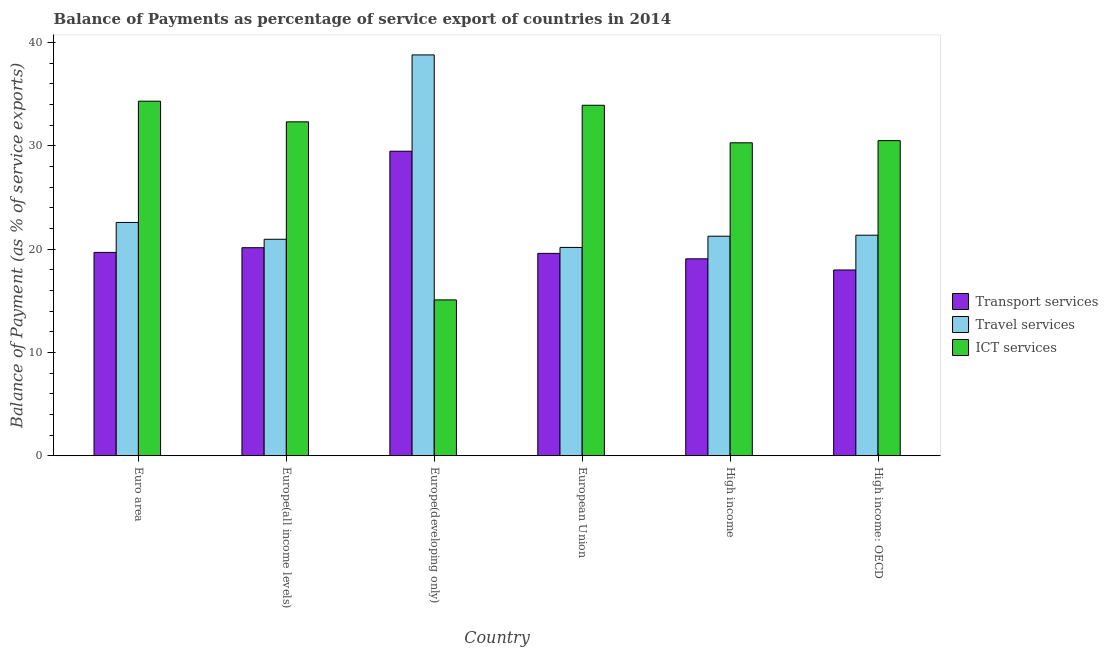How many different coloured bars are there?
Your answer should be compact. 3. How many groups of bars are there?
Keep it short and to the point. 6. How many bars are there on the 6th tick from the right?
Your answer should be compact. 3. What is the label of the 6th group of bars from the left?
Keep it short and to the point. High income: OECD. What is the balance of payment of ict services in Euro area?
Your answer should be compact. 34.34. Across all countries, what is the maximum balance of payment of travel services?
Keep it short and to the point. 38.82. Across all countries, what is the minimum balance of payment of travel services?
Your response must be concise. 20.17. In which country was the balance of payment of ict services maximum?
Keep it short and to the point. Euro area. What is the total balance of payment of ict services in the graph?
Ensure brevity in your answer.  176.52. What is the difference between the balance of payment of transport services in Euro area and that in High income?
Your answer should be very brief. 0.62. What is the difference between the balance of payment of transport services in European Union and the balance of payment of ict services in Europe(developing only)?
Your answer should be compact. 4.5. What is the average balance of payment of ict services per country?
Provide a succinct answer. 29.42. What is the difference between the balance of payment of transport services and balance of payment of travel services in Europe(all income levels)?
Your answer should be very brief. -0.82. In how many countries, is the balance of payment of travel services greater than 32 %?
Provide a short and direct response. 1. What is the ratio of the balance of payment of ict services in Euro area to that in Europe(developing only)?
Provide a short and direct response. 2.28. Is the difference between the balance of payment of transport services in Europe(all income levels) and Europe(developing only) greater than the difference between the balance of payment of travel services in Europe(all income levels) and Europe(developing only)?
Offer a terse response. Yes. What is the difference between the highest and the second highest balance of payment of transport services?
Your response must be concise. 9.34. What is the difference between the highest and the lowest balance of payment of transport services?
Keep it short and to the point. 11.5. What does the 1st bar from the left in Euro area represents?
Give a very brief answer. Transport services. What does the 3rd bar from the right in Europe(developing only) represents?
Offer a terse response. Transport services. Is it the case that in every country, the sum of the balance of payment of transport services and balance of payment of travel services is greater than the balance of payment of ict services?
Offer a very short reply. Yes. Are all the bars in the graph horizontal?
Offer a terse response. No. What is the difference between two consecutive major ticks on the Y-axis?
Your answer should be compact. 10. Are the values on the major ticks of Y-axis written in scientific E-notation?
Provide a short and direct response. No. Where does the legend appear in the graph?
Offer a very short reply. Center right. What is the title of the graph?
Make the answer very short. Balance of Payments as percentage of service export of countries in 2014. What is the label or title of the X-axis?
Offer a terse response. Country. What is the label or title of the Y-axis?
Your response must be concise. Balance of Payment (as % of service exports). What is the Balance of Payment (as % of service exports) in Transport services in Euro area?
Give a very brief answer. 19.69. What is the Balance of Payment (as % of service exports) in Travel services in Euro area?
Provide a succinct answer. 22.59. What is the Balance of Payment (as % of service exports) in ICT services in Euro area?
Provide a succinct answer. 34.34. What is the Balance of Payment (as % of service exports) in Transport services in Europe(all income levels)?
Offer a terse response. 20.15. What is the Balance of Payment (as % of service exports) in Travel services in Europe(all income levels)?
Give a very brief answer. 20.96. What is the Balance of Payment (as % of service exports) in ICT services in Europe(all income levels)?
Your answer should be compact. 32.34. What is the Balance of Payment (as % of service exports) in Transport services in Europe(developing only)?
Make the answer very short. 29.49. What is the Balance of Payment (as % of service exports) in Travel services in Europe(developing only)?
Provide a succinct answer. 38.82. What is the Balance of Payment (as % of service exports) in ICT services in Europe(developing only)?
Your answer should be compact. 15.09. What is the Balance of Payment (as % of service exports) in Transport services in European Union?
Ensure brevity in your answer.  19.6. What is the Balance of Payment (as % of service exports) of Travel services in European Union?
Ensure brevity in your answer.  20.17. What is the Balance of Payment (as % of service exports) in ICT services in European Union?
Ensure brevity in your answer.  33.94. What is the Balance of Payment (as % of service exports) in Transport services in High income?
Ensure brevity in your answer.  19.07. What is the Balance of Payment (as % of service exports) of Travel services in High income?
Offer a very short reply. 21.26. What is the Balance of Payment (as % of service exports) of ICT services in High income?
Your answer should be very brief. 30.3. What is the Balance of Payment (as % of service exports) in Transport services in High income: OECD?
Ensure brevity in your answer.  17.99. What is the Balance of Payment (as % of service exports) of Travel services in High income: OECD?
Ensure brevity in your answer.  21.36. What is the Balance of Payment (as % of service exports) in ICT services in High income: OECD?
Offer a very short reply. 30.52. Across all countries, what is the maximum Balance of Payment (as % of service exports) of Transport services?
Offer a very short reply. 29.49. Across all countries, what is the maximum Balance of Payment (as % of service exports) in Travel services?
Offer a terse response. 38.82. Across all countries, what is the maximum Balance of Payment (as % of service exports) in ICT services?
Keep it short and to the point. 34.34. Across all countries, what is the minimum Balance of Payment (as % of service exports) in Transport services?
Give a very brief answer. 17.99. Across all countries, what is the minimum Balance of Payment (as % of service exports) of Travel services?
Offer a very short reply. 20.17. Across all countries, what is the minimum Balance of Payment (as % of service exports) of ICT services?
Offer a very short reply. 15.09. What is the total Balance of Payment (as % of service exports) in Transport services in the graph?
Make the answer very short. 125.98. What is the total Balance of Payment (as % of service exports) in Travel services in the graph?
Your answer should be compact. 145.16. What is the total Balance of Payment (as % of service exports) in ICT services in the graph?
Your answer should be compact. 176.52. What is the difference between the Balance of Payment (as % of service exports) of Transport services in Euro area and that in Europe(all income levels)?
Your response must be concise. -0.45. What is the difference between the Balance of Payment (as % of service exports) of Travel services in Euro area and that in Europe(all income levels)?
Ensure brevity in your answer.  1.63. What is the difference between the Balance of Payment (as % of service exports) of ICT services in Euro area and that in Europe(all income levels)?
Ensure brevity in your answer.  2. What is the difference between the Balance of Payment (as % of service exports) in Transport services in Euro area and that in Europe(developing only)?
Offer a terse response. -9.8. What is the difference between the Balance of Payment (as % of service exports) in Travel services in Euro area and that in Europe(developing only)?
Your answer should be compact. -16.23. What is the difference between the Balance of Payment (as % of service exports) in ICT services in Euro area and that in Europe(developing only)?
Provide a short and direct response. 19.24. What is the difference between the Balance of Payment (as % of service exports) in Transport services in Euro area and that in European Union?
Offer a terse response. 0.1. What is the difference between the Balance of Payment (as % of service exports) of Travel services in Euro area and that in European Union?
Offer a very short reply. 2.42. What is the difference between the Balance of Payment (as % of service exports) of ICT services in Euro area and that in European Union?
Give a very brief answer. 0.4. What is the difference between the Balance of Payment (as % of service exports) of Transport services in Euro area and that in High income?
Offer a terse response. 0.62. What is the difference between the Balance of Payment (as % of service exports) of Travel services in Euro area and that in High income?
Keep it short and to the point. 1.33. What is the difference between the Balance of Payment (as % of service exports) in ICT services in Euro area and that in High income?
Make the answer very short. 4.03. What is the difference between the Balance of Payment (as % of service exports) of Transport services in Euro area and that in High income: OECD?
Offer a very short reply. 1.7. What is the difference between the Balance of Payment (as % of service exports) in Travel services in Euro area and that in High income: OECD?
Offer a terse response. 1.23. What is the difference between the Balance of Payment (as % of service exports) in ICT services in Euro area and that in High income: OECD?
Your answer should be compact. 3.82. What is the difference between the Balance of Payment (as % of service exports) of Transport services in Europe(all income levels) and that in Europe(developing only)?
Provide a succinct answer. -9.34. What is the difference between the Balance of Payment (as % of service exports) of Travel services in Europe(all income levels) and that in Europe(developing only)?
Provide a short and direct response. -17.85. What is the difference between the Balance of Payment (as % of service exports) of ICT services in Europe(all income levels) and that in Europe(developing only)?
Your answer should be very brief. 17.24. What is the difference between the Balance of Payment (as % of service exports) in Transport services in Europe(all income levels) and that in European Union?
Give a very brief answer. 0.55. What is the difference between the Balance of Payment (as % of service exports) in Travel services in Europe(all income levels) and that in European Union?
Give a very brief answer. 0.79. What is the difference between the Balance of Payment (as % of service exports) of ICT services in Europe(all income levels) and that in European Union?
Offer a terse response. -1.6. What is the difference between the Balance of Payment (as % of service exports) in Transport services in Europe(all income levels) and that in High income?
Your answer should be compact. 1.08. What is the difference between the Balance of Payment (as % of service exports) of Travel services in Europe(all income levels) and that in High income?
Your answer should be compact. -0.3. What is the difference between the Balance of Payment (as % of service exports) of ICT services in Europe(all income levels) and that in High income?
Give a very brief answer. 2.03. What is the difference between the Balance of Payment (as % of service exports) of Transport services in Europe(all income levels) and that in High income: OECD?
Your answer should be very brief. 2.16. What is the difference between the Balance of Payment (as % of service exports) of Travel services in Europe(all income levels) and that in High income: OECD?
Make the answer very short. -0.4. What is the difference between the Balance of Payment (as % of service exports) of ICT services in Europe(all income levels) and that in High income: OECD?
Offer a terse response. 1.82. What is the difference between the Balance of Payment (as % of service exports) in Transport services in Europe(developing only) and that in European Union?
Make the answer very short. 9.89. What is the difference between the Balance of Payment (as % of service exports) in Travel services in Europe(developing only) and that in European Union?
Provide a short and direct response. 18.64. What is the difference between the Balance of Payment (as % of service exports) of ICT services in Europe(developing only) and that in European Union?
Your answer should be compact. -18.85. What is the difference between the Balance of Payment (as % of service exports) in Transport services in Europe(developing only) and that in High income?
Make the answer very short. 10.42. What is the difference between the Balance of Payment (as % of service exports) in Travel services in Europe(developing only) and that in High income?
Keep it short and to the point. 17.56. What is the difference between the Balance of Payment (as % of service exports) of ICT services in Europe(developing only) and that in High income?
Give a very brief answer. -15.21. What is the difference between the Balance of Payment (as % of service exports) of Transport services in Europe(developing only) and that in High income: OECD?
Offer a terse response. 11.5. What is the difference between the Balance of Payment (as % of service exports) in Travel services in Europe(developing only) and that in High income: OECD?
Ensure brevity in your answer.  17.46. What is the difference between the Balance of Payment (as % of service exports) in ICT services in Europe(developing only) and that in High income: OECD?
Offer a very short reply. -15.42. What is the difference between the Balance of Payment (as % of service exports) of Transport services in European Union and that in High income?
Offer a very short reply. 0.53. What is the difference between the Balance of Payment (as % of service exports) of Travel services in European Union and that in High income?
Keep it short and to the point. -1.09. What is the difference between the Balance of Payment (as % of service exports) in ICT services in European Union and that in High income?
Ensure brevity in your answer.  3.64. What is the difference between the Balance of Payment (as % of service exports) of Transport services in European Union and that in High income: OECD?
Provide a succinct answer. 1.61. What is the difference between the Balance of Payment (as % of service exports) of Travel services in European Union and that in High income: OECD?
Offer a very short reply. -1.19. What is the difference between the Balance of Payment (as % of service exports) in ICT services in European Union and that in High income: OECD?
Your answer should be very brief. 3.42. What is the difference between the Balance of Payment (as % of service exports) of Transport services in High income and that in High income: OECD?
Ensure brevity in your answer.  1.08. What is the difference between the Balance of Payment (as % of service exports) in Travel services in High income and that in High income: OECD?
Provide a succinct answer. -0.1. What is the difference between the Balance of Payment (as % of service exports) in ICT services in High income and that in High income: OECD?
Ensure brevity in your answer.  -0.21. What is the difference between the Balance of Payment (as % of service exports) in Transport services in Euro area and the Balance of Payment (as % of service exports) in Travel services in Europe(all income levels)?
Provide a short and direct response. -1.27. What is the difference between the Balance of Payment (as % of service exports) of Transport services in Euro area and the Balance of Payment (as % of service exports) of ICT services in Europe(all income levels)?
Make the answer very short. -12.64. What is the difference between the Balance of Payment (as % of service exports) in Travel services in Euro area and the Balance of Payment (as % of service exports) in ICT services in Europe(all income levels)?
Provide a succinct answer. -9.74. What is the difference between the Balance of Payment (as % of service exports) of Transport services in Euro area and the Balance of Payment (as % of service exports) of Travel services in Europe(developing only)?
Offer a very short reply. -19.12. What is the difference between the Balance of Payment (as % of service exports) of Transport services in Euro area and the Balance of Payment (as % of service exports) of ICT services in Europe(developing only)?
Make the answer very short. 4.6. What is the difference between the Balance of Payment (as % of service exports) of Travel services in Euro area and the Balance of Payment (as % of service exports) of ICT services in Europe(developing only)?
Your answer should be very brief. 7.5. What is the difference between the Balance of Payment (as % of service exports) in Transport services in Euro area and the Balance of Payment (as % of service exports) in Travel services in European Union?
Your answer should be very brief. -0.48. What is the difference between the Balance of Payment (as % of service exports) in Transport services in Euro area and the Balance of Payment (as % of service exports) in ICT services in European Union?
Provide a short and direct response. -14.25. What is the difference between the Balance of Payment (as % of service exports) of Travel services in Euro area and the Balance of Payment (as % of service exports) of ICT services in European Union?
Your answer should be very brief. -11.35. What is the difference between the Balance of Payment (as % of service exports) of Transport services in Euro area and the Balance of Payment (as % of service exports) of Travel services in High income?
Keep it short and to the point. -1.57. What is the difference between the Balance of Payment (as % of service exports) of Transport services in Euro area and the Balance of Payment (as % of service exports) of ICT services in High income?
Give a very brief answer. -10.61. What is the difference between the Balance of Payment (as % of service exports) of Travel services in Euro area and the Balance of Payment (as % of service exports) of ICT services in High income?
Give a very brief answer. -7.71. What is the difference between the Balance of Payment (as % of service exports) in Transport services in Euro area and the Balance of Payment (as % of service exports) in Travel services in High income: OECD?
Keep it short and to the point. -1.67. What is the difference between the Balance of Payment (as % of service exports) in Transport services in Euro area and the Balance of Payment (as % of service exports) in ICT services in High income: OECD?
Your answer should be compact. -10.82. What is the difference between the Balance of Payment (as % of service exports) of Travel services in Euro area and the Balance of Payment (as % of service exports) of ICT services in High income: OECD?
Provide a short and direct response. -7.92. What is the difference between the Balance of Payment (as % of service exports) in Transport services in Europe(all income levels) and the Balance of Payment (as % of service exports) in Travel services in Europe(developing only)?
Make the answer very short. -18.67. What is the difference between the Balance of Payment (as % of service exports) in Transport services in Europe(all income levels) and the Balance of Payment (as % of service exports) in ICT services in Europe(developing only)?
Your response must be concise. 5.05. What is the difference between the Balance of Payment (as % of service exports) in Travel services in Europe(all income levels) and the Balance of Payment (as % of service exports) in ICT services in Europe(developing only)?
Provide a succinct answer. 5.87. What is the difference between the Balance of Payment (as % of service exports) of Transport services in Europe(all income levels) and the Balance of Payment (as % of service exports) of Travel services in European Union?
Your answer should be very brief. -0.03. What is the difference between the Balance of Payment (as % of service exports) of Transport services in Europe(all income levels) and the Balance of Payment (as % of service exports) of ICT services in European Union?
Ensure brevity in your answer.  -13.79. What is the difference between the Balance of Payment (as % of service exports) in Travel services in Europe(all income levels) and the Balance of Payment (as % of service exports) in ICT services in European Union?
Your answer should be very brief. -12.98. What is the difference between the Balance of Payment (as % of service exports) of Transport services in Europe(all income levels) and the Balance of Payment (as % of service exports) of Travel services in High income?
Your answer should be very brief. -1.11. What is the difference between the Balance of Payment (as % of service exports) in Transport services in Europe(all income levels) and the Balance of Payment (as % of service exports) in ICT services in High income?
Your answer should be compact. -10.16. What is the difference between the Balance of Payment (as % of service exports) in Travel services in Europe(all income levels) and the Balance of Payment (as % of service exports) in ICT services in High income?
Your response must be concise. -9.34. What is the difference between the Balance of Payment (as % of service exports) of Transport services in Europe(all income levels) and the Balance of Payment (as % of service exports) of Travel services in High income: OECD?
Provide a short and direct response. -1.21. What is the difference between the Balance of Payment (as % of service exports) of Transport services in Europe(all income levels) and the Balance of Payment (as % of service exports) of ICT services in High income: OECD?
Offer a terse response. -10.37. What is the difference between the Balance of Payment (as % of service exports) in Travel services in Europe(all income levels) and the Balance of Payment (as % of service exports) in ICT services in High income: OECD?
Offer a terse response. -9.55. What is the difference between the Balance of Payment (as % of service exports) in Transport services in Europe(developing only) and the Balance of Payment (as % of service exports) in Travel services in European Union?
Provide a short and direct response. 9.32. What is the difference between the Balance of Payment (as % of service exports) of Transport services in Europe(developing only) and the Balance of Payment (as % of service exports) of ICT services in European Union?
Your answer should be compact. -4.45. What is the difference between the Balance of Payment (as % of service exports) of Travel services in Europe(developing only) and the Balance of Payment (as % of service exports) of ICT services in European Union?
Offer a very short reply. 4.88. What is the difference between the Balance of Payment (as % of service exports) in Transport services in Europe(developing only) and the Balance of Payment (as % of service exports) in Travel services in High income?
Your response must be concise. 8.23. What is the difference between the Balance of Payment (as % of service exports) in Transport services in Europe(developing only) and the Balance of Payment (as % of service exports) in ICT services in High income?
Offer a terse response. -0.81. What is the difference between the Balance of Payment (as % of service exports) of Travel services in Europe(developing only) and the Balance of Payment (as % of service exports) of ICT services in High income?
Your answer should be compact. 8.51. What is the difference between the Balance of Payment (as % of service exports) in Transport services in Europe(developing only) and the Balance of Payment (as % of service exports) in Travel services in High income: OECD?
Make the answer very short. 8.13. What is the difference between the Balance of Payment (as % of service exports) in Transport services in Europe(developing only) and the Balance of Payment (as % of service exports) in ICT services in High income: OECD?
Offer a terse response. -1.02. What is the difference between the Balance of Payment (as % of service exports) in Travel services in Europe(developing only) and the Balance of Payment (as % of service exports) in ICT services in High income: OECD?
Your answer should be very brief. 8.3. What is the difference between the Balance of Payment (as % of service exports) in Transport services in European Union and the Balance of Payment (as % of service exports) in Travel services in High income?
Keep it short and to the point. -1.66. What is the difference between the Balance of Payment (as % of service exports) of Transport services in European Union and the Balance of Payment (as % of service exports) of ICT services in High income?
Make the answer very short. -10.71. What is the difference between the Balance of Payment (as % of service exports) of Travel services in European Union and the Balance of Payment (as % of service exports) of ICT services in High income?
Offer a terse response. -10.13. What is the difference between the Balance of Payment (as % of service exports) of Transport services in European Union and the Balance of Payment (as % of service exports) of Travel services in High income: OECD?
Keep it short and to the point. -1.76. What is the difference between the Balance of Payment (as % of service exports) of Transport services in European Union and the Balance of Payment (as % of service exports) of ICT services in High income: OECD?
Offer a very short reply. -10.92. What is the difference between the Balance of Payment (as % of service exports) of Travel services in European Union and the Balance of Payment (as % of service exports) of ICT services in High income: OECD?
Offer a terse response. -10.34. What is the difference between the Balance of Payment (as % of service exports) of Transport services in High income and the Balance of Payment (as % of service exports) of Travel services in High income: OECD?
Keep it short and to the point. -2.29. What is the difference between the Balance of Payment (as % of service exports) in Transport services in High income and the Balance of Payment (as % of service exports) in ICT services in High income: OECD?
Your answer should be compact. -11.45. What is the difference between the Balance of Payment (as % of service exports) in Travel services in High income and the Balance of Payment (as % of service exports) in ICT services in High income: OECD?
Your response must be concise. -9.26. What is the average Balance of Payment (as % of service exports) in Transport services per country?
Your answer should be very brief. 21. What is the average Balance of Payment (as % of service exports) in Travel services per country?
Your answer should be very brief. 24.19. What is the average Balance of Payment (as % of service exports) of ICT services per country?
Offer a very short reply. 29.42. What is the difference between the Balance of Payment (as % of service exports) of Transport services and Balance of Payment (as % of service exports) of Travel services in Euro area?
Offer a very short reply. -2.9. What is the difference between the Balance of Payment (as % of service exports) in Transport services and Balance of Payment (as % of service exports) in ICT services in Euro area?
Your response must be concise. -14.64. What is the difference between the Balance of Payment (as % of service exports) of Travel services and Balance of Payment (as % of service exports) of ICT services in Euro area?
Keep it short and to the point. -11.74. What is the difference between the Balance of Payment (as % of service exports) of Transport services and Balance of Payment (as % of service exports) of Travel services in Europe(all income levels)?
Your answer should be compact. -0.82. What is the difference between the Balance of Payment (as % of service exports) of Transport services and Balance of Payment (as % of service exports) of ICT services in Europe(all income levels)?
Your answer should be compact. -12.19. What is the difference between the Balance of Payment (as % of service exports) in Travel services and Balance of Payment (as % of service exports) in ICT services in Europe(all income levels)?
Offer a terse response. -11.37. What is the difference between the Balance of Payment (as % of service exports) in Transport services and Balance of Payment (as % of service exports) in Travel services in Europe(developing only)?
Make the answer very short. -9.33. What is the difference between the Balance of Payment (as % of service exports) of Transport services and Balance of Payment (as % of service exports) of ICT services in Europe(developing only)?
Ensure brevity in your answer.  14.4. What is the difference between the Balance of Payment (as % of service exports) of Travel services and Balance of Payment (as % of service exports) of ICT services in Europe(developing only)?
Offer a terse response. 23.72. What is the difference between the Balance of Payment (as % of service exports) of Transport services and Balance of Payment (as % of service exports) of Travel services in European Union?
Your answer should be compact. -0.58. What is the difference between the Balance of Payment (as % of service exports) of Transport services and Balance of Payment (as % of service exports) of ICT services in European Union?
Your response must be concise. -14.34. What is the difference between the Balance of Payment (as % of service exports) in Travel services and Balance of Payment (as % of service exports) in ICT services in European Union?
Ensure brevity in your answer.  -13.77. What is the difference between the Balance of Payment (as % of service exports) of Transport services and Balance of Payment (as % of service exports) of Travel services in High income?
Give a very brief answer. -2.19. What is the difference between the Balance of Payment (as % of service exports) in Transport services and Balance of Payment (as % of service exports) in ICT services in High income?
Keep it short and to the point. -11.23. What is the difference between the Balance of Payment (as % of service exports) in Travel services and Balance of Payment (as % of service exports) in ICT services in High income?
Make the answer very short. -9.04. What is the difference between the Balance of Payment (as % of service exports) of Transport services and Balance of Payment (as % of service exports) of Travel services in High income: OECD?
Give a very brief answer. -3.37. What is the difference between the Balance of Payment (as % of service exports) of Transport services and Balance of Payment (as % of service exports) of ICT services in High income: OECD?
Provide a short and direct response. -12.53. What is the difference between the Balance of Payment (as % of service exports) of Travel services and Balance of Payment (as % of service exports) of ICT services in High income: OECD?
Your answer should be very brief. -9.16. What is the ratio of the Balance of Payment (as % of service exports) of Transport services in Euro area to that in Europe(all income levels)?
Your response must be concise. 0.98. What is the ratio of the Balance of Payment (as % of service exports) of Travel services in Euro area to that in Europe(all income levels)?
Give a very brief answer. 1.08. What is the ratio of the Balance of Payment (as % of service exports) in ICT services in Euro area to that in Europe(all income levels)?
Give a very brief answer. 1.06. What is the ratio of the Balance of Payment (as % of service exports) in Transport services in Euro area to that in Europe(developing only)?
Keep it short and to the point. 0.67. What is the ratio of the Balance of Payment (as % of service exports) in Travel services in Euro area to that in Europe(developing only)?
Keep it short and to the point. 0.58. What is the ratio of the Balance of Payment (as % of service exports) of ICT services in Euro area to that in Europe(developing only)?
Offer a very short reply. 2.28. What is the ratio of the Balance of Payment (as % of service exports) of Travel services in Euro area to that in European Union?
Provide a succinct answer. 1.12. What is the ratio of the Balance of Payment (as % of service exports) of ICT services in Euro area to that in European Union?
Provide a succinct answer. 1.01. What is the ratio of the Balance of Payment (as % of service exports) of Transport services in Euro area to that in High income?
Your response must be concise. 1.03. What is the ratio of the Balance of Payment (as % of service exports) of Travel services in Euro area to that in High income?
Ensure brevity in your answer.  1.06. What is the ratio of the Balance of Payment (as % of service exports) of ICT services in Euro area to that in High income?
Your response must be concise. 1.13. What is the ratio of the Balance of Payment (as % of service exports) of Transport services in Euro area to that in High income: OECD?
Offer a very short reply. 1.09. What is the ratio of the Balance of Payment (as % of service exports) of Travel services in Euro area to that in High income: OECD?
Your response must be concise. 1.06. What is the ratio of the Balance of Payment (as % of service exports) in ICT services in Euro area to that in High income: OECD?
Offer a terse response. 1.13. What is the ratio of the Balance of Payment (as % of service exports) of Transport services in Europe(all income levels) to that in Europe(developing only)?
Provide a short and direct response. 0.68. What is the ratio of the Balance of Payment (as % of service exports) of Travel services in Europe(all income levels) to that in Europe(developing only)?
Offer a terse response. 0.54. What is the ratio of the Balance of Payment (as % of service exports) in ICT services in Europe(all income levels) to that in Europe(developing only)?
Keep it short and to the point. 2.14. What is the ratio of the Balance of Payment (as % of service exports) in Transport services in Europe(all income levels) to that in European Union?
Your response must be concise. 1.03. What is the ratio of the Balance of Payment (as % of service exports) in Travel services in Europe(all income levels) to that in European Union?
Give a very brief answer. 1.04. What is the ratio of the Balance of Payment (as % of service exports) in ICT services in Europe(all income levels) to that in European Union?
Provide a succinct answer. 0.95. What is the ratio of the Balance of Payment (as % of service exports) in Transport services in Europe(all income levels) to that in High income?
Ensure brevity in your answer.  1.06. What is the ratio of the Balance of Payment (as % of service exports) of ICT services in Europe(all income levels) to that in High income?
Keep it short and to the point. 1.07. What is the ratio of the Balance of Payment (as % of service exports) of Transport services in Europe(all income levels) to that in High income: OECD?
Your response must be concise. 1.12. What is the ratio of the Balance of Payment (as % of service exports) of Travel services in Europe(all income levels) to that in High income: OECD?
Give a very brief answer. 0.98. What is the ratio of the Balance of Payment (as % of service exports) of ICT services in Europe(all income levels) to that in High income: OECD?
Offer a terse response. 1.06. What is the ratio of the Balance of Payment (as % of service exports) in Transport services in Europe(developing only) to that in European Union?
Your response must be concise. 1.5. What is the ratio of the Balance of Payment (as % of service exports) in Travel services in Europe(developing only) to that in European Union?
Your answer should be very brief. 1.92. What is the ratio of the Balance of Payment (as % of service exports) of ICT services in Europe(developing only) to that in European Union?
Offer a terse response. 0.44. What is the ratio of the Balance of Payment (as % of service exports) in Transport services in Europe(developing only) to that in High income?
Offer a very short reply. 1.55. What is the ratio of the Balance of Payment (as % of service exports) of Travel services in Europe(developing only) to that in High income?
Offer a terse response. 1.83. What is the ratio of the Balance of Payment (as % of service exports) of ICT services in Europe(developing only) to that in High income?
Your answer should be compact. 0.5. What is the ratio of the Balance of Payment (as % of service exports) of Transport services in Europe(developing only) to that in High income: OECD?
Your answer should be compact. 1.64. What is the ratio of the Balance of Payment (as % of service exports) of Travel services in Europe(developing only) to that in High income: OECD?
Your answer should be very brief. 1.82. What is the ratio of the Balance of Payment (as % of service exports) in ICT services in Europe(developing only) to that in High income: OECD?
Your answer should be compact. 0.49. What is the ratio of the Balance of Payment (as % of service exports) of Transport services in European Union to that in High income?
Provide a succinct answer. 1.03. What is the ratio of the Balance of Payment (as % of service exports) in Travel services in European Union to that in High income?
Your answer should be compact. 0.95. What is the ratio of the Balance of Payment (as % of service exports) of ICT services in European Union to that in High income?
Keep it short and to the point. 1.12. What is the ratio of the Balance of Payment (as % of service exports) in Transport services in European Union to that in High income: OECD?
Your answer should be compact. 1.09. What is the ratio of the Balance of Payment (as % of service exports) of Travel services in European Union to that in High income: OECD?
Ensure brevity in your answer.  0.94. What is the ratio of the Balance of Payment (as % of service exports) of ICT services in European Union to that in High income: OECD?
Make the answer very short. 1.11. What is the ratio of the Balance of Payment (as % of service exports) in Transport services in High income to that in High income: OECD?
Make the answer very short. 1.06. What is the difference between the highest and the second highest Balance of Payment (as % of service exports) in Transport services?
Provide a short and direct response. 9.34. What is the difference between the highest and the second highest Balance of Payment (as % of service exports) of Travel services?
Your response must be concise. 16.23. What is the difference between the highest and the second highest Balance of Payment (as % of service exports) of ICT services?
Ensure brevity in your answer.  0.4. What is the difference between the highest and the lowest Balance of Payment (as % of service exports) of Transport services?
Offer a very short reply. 11.5. What is the difference between the highest and the lowest Balance of Payment (as % of service exports) of Travel services?
Your answer should be compact. 18.64. What is the difference between the highest and the lowest Balance of Payment (as % of service exports) of ICT services?
Your response must be concise. 19.24. 